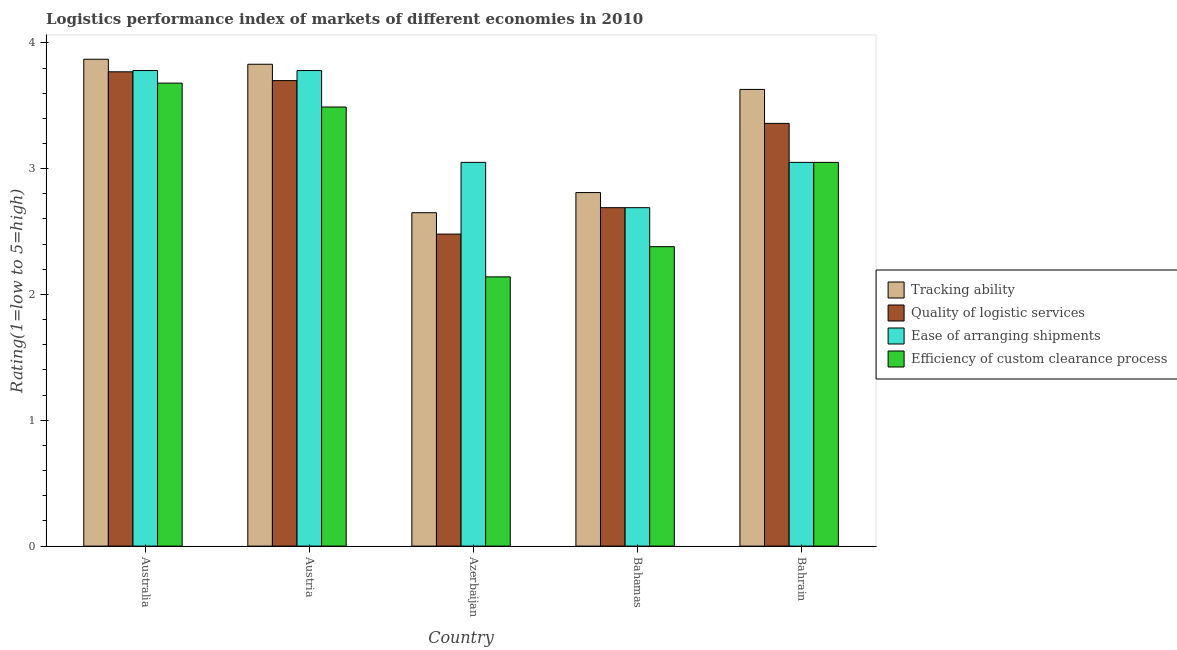How many groups of bars are there?
Make the answer very short. 5. Are the number of bars per tick equal to the number of legend labels?
Keep it short and to the point. Yes. Are the number of bars on each tick of the X-axis equal?
Offer a terse response. Yes. How many bars are there on the 3rd tick from the left?
Give a very brief answer. 4. What is the label of the 5th group of bars from the left?
Your response must be concise. Bahrain. What is the lpi rating of tracking ability in Bahamas?
Make the answer very short. 2.81. Across all countries, what is the maximum lpi rating of efficiency of custom clearance process?
Give a very brief answer. 3.68. Across all countries, what is the minimum lpi rating of quality of logistic services?
Make the answer very short. 2.48. In which country was the lpi rating of efficiency of custom clearance process maximum?
Offer a very short reply. Australia. In which country was the lpi rating of tracking ability minimum?
Offer a very short reply. Azerbaijan. What is the total lpi rating of quality of logistic services in the graph?
Your answer should be compact. 16. What is the difference between the lpi rating of tracking ability in Austria and that in Bahrain?
Your response must be concise. 0.2. What is the difference between the lpi rating of efficiency of custom clearance process in Bahamas and the lpi rating of quality of logistic services in Azerbaijan?
Make the answer very short. -0.1. What is the average lpi rating of ease of arranging shipments per country?
Provide a succinct answer. 3.27. What is the difference between the lpi rating of efficiency of custom clearance process and lpi rating of quality of logistic services in Australia?
Give a very brief answer. -0.09. What is the ratio of the lpi rating of tracking ability in Azerbaijan to that in Bahamas?
Keep it short and to the point. 0.94. Is the lpi rating of tracking ability in Australia less than that in Azerbaijan?
Your answer should be very brief. No. Is the difference between the lpi rating of efficiency of custom clearance process in Australia and Bahrain greater than the difference between the lpi rating of tracking ability in Australia and Bahrain?
Make the answer very short. Yes. What is the difference between the highest and the second highest lpi rating of quality of logistic services?
Offer a terse response. 0.07. What is the difference between the highest and the lowest lpi rating of efficiency of custom clearance process?
Keep it short and to the point. 1.54. In how many countries, is the lpi rating of ease of arranging shipments greater than the average lpi rating of ease of arranging shipments taken over all countries?
Ensure brevity in your answer.  2. Is the sum of the lpi rating of quality of logistic services in Austria and Bahrain greater than the maximum lpi rating of tracking ability across all countries?
Give a very brief answer. Yes. What does the 4th bar from the left in Austria represents?
Make the answer very short. Efficiency of custom clearance process. What does the 1st bar from the right in Bahrain represents?
Give a very brief answer. Efficiency of custom clearance process. Is it the case that in every country, the sum of the lpi rating of tracking ability and lpi rating of quality of logistic services is greater than the lpi rating of ease of arranging shipments?
Ensure brevity in your answer.  Yes. How many bars are there?
Provide a succinct answer. 20. Are all the bars in the graph horizontal?
Keep it short and to the point. No. How many countries are there in the graph?
Provide a short and direct response. 5. What is the difference between two consecutive major ticks on the Y-axis?
Offer a very short reply. 1. Where does the legend appear in the graph?
Your answer should be very brief. Center right. What is the title of the graph?
Keep it short and to the point. Logistics performance index of markets of different economies in 2010. Does "Italy" appear as one of the legend labels in the graph?
Your answer should be very brief. No. What is the label or title of the Y-axis?
Give a very brief answer. Rating(1=low to 5=high). What is the Rating(1=low to 5=high) of Tracking ability in Australia?
Give a very brief answer. 3.87. What is the Rating(1=low to 5=high) in Quality of logistic services in Australia?
Your answer should be very brief. 3.77. What is the Rating(1=low to 5=high) in Ease of arranging shipments in Australia?
Your response must be concise. 3.78. What is the Rating(1=low to 5=high) in Efficiency of custom clearance process in Australia?
Your answer should be very brief. 3.68. What is the Rating(1=low to 5=high) of Tracking ability in Austria?
Offer a terse response. 3.83. What is the Rating(1=low to 5=high) of Ease of arranging shipments in Austria?
Keep it short and to the point. 3.78. What is the Rating(1=low to 5=high) in Efficiency of custom clearance process in Austria?
Your response must be concise. 3.49. What is the Rating(1=low to 5=high) in Tracking ability in Azerbaijan?
Provide a short and direct response. 2.65. What is the Rating(1=low to 5=high) in Quality of logistic services in Azerbaijan?
Keep it short and to the point. 2.48. What is the Rating(1=low to 5=high) of Ease of arranging shipments in Azerbaijan?
Give a very brief answer. 3.05. What is the Rating(1=low to 5=high) of Efficiency of custom clearance process in Azerbaijan?
Offer a very short reply. 2.14. What is the Rating(1=low to 5=high) of Tracking ability in Bahamas?
Make the answer very short. 2.81. What is the Rating(1=low to 5=high) of Quality of logistic services in Bahamas?
Make the answer very short. 2.69. What is the Rating(1=low to 5=high) of Ease of arranging shipments in Bahamas?
Provide a succinct answer. 2.69. What is the Rating(1=low to 5=high) of Efficiency of custom clearance process in Bahamas?
Offer a very short reply. 2.38. What is the Rating(1=low to 5=high) of Tracking ability in Bahrain?
Offer a very short reply. 3.63. What is the Rating(1=low to 5=high) in Quality of logistic services in Bahrain?
Your answer should be compact. 3.36. What is the Rating(1=low to 5=high) in Ease of arranging shipments in Bahrain?
Your answer should be very brief. 3.05. What is the Rating(1=low to 5=high) of Efficiency of custom clearance process in Bahrain?
Provide a succinct answer. 3.05. Across all countries, what is the maximum Rating(1=low to 5=high) in Tracking ability?
Give a very brief answer. 3.87. Across all countries, what is the maximum Rating(1=low to 5=high) in Quality of logistic services?
Offer a very short reply. 3.77. Across all countries, what is the maximum Rating(1=low to 5=high) of Ease of arranging shipments?
Offer a terse response. 3.78. Across all countries, what is the maximum Rating(1=low to 5=high) in Efficiency of custom clearance process?
Your answer should be compact. 3.68. Across all countries, what is the minimum Rating(1=low to 5=high) of Tracking ability?
Provide a succinct answer. 2.65. Across all countries, what is the minimum Rating(1=low to 5=high) of Quality of logistic services?
Ensure brevity in your answer.  2.48. Across all countries, what is the minimum Rating(1=low to 5=high) in Ease of arranging shipments?
Your answer should be compact. 2.69. Across all countries, what is the minimum Rating(1=low to 5=high) of Efficiency of custom clearance process?
Keep it short and to the point. 2.14. What is the total Rating(1=low to 5=high) of Tracking ability in the graph?
Keep it short and to the point. 16.79. What is the total Rating(1=low to 5=high) of Quality of logistic services in the graph?
Offer a very short reply. 16. What is the total Rating(1=low to 5=high) of Ease of arranging shipments in the graph?
Your answer should be compact. 16.35. What is the total Rating(1=low to 5=high) of Efficiency of custom clearance process in the graph?
Offer a terse response. 14.74. What is the difference between the Rating(1=low to 5=high) of Quality of logistic services in Australia and that in Austria?
Offer a very short reply. 0.07. What is the difference between the Rating(1=low to 5=high) in Ease of arranging shipments in Australia and that in Austria?
Offer a very short reply. 0. What is the difference between the Rating(1=low to 5=high) in Efficiency of custom clearance process in Australia and that in Austria?
Offer a terse response. 0.19. What is the difference between the Rating(1=low to 5=high) in Tracking ability in Australia and that in Azerbaijan?
Give a very brief answer. 1.22. What is the difference between the Rating(1=low to 5=high) in Quality of logistic services in Australia and that in Azerbaijan?
Keep it short and to the point. 1.29. What is the difference between the Rating(1=low to 5=high) in Ease of arranging shipments in Australia and that in Azerbaijan?
Provide a succinct answer. 0.73. What is the difference between the Rating(1=low to 5=high) of Efficiency of custom clearance process in Australia and that in Azerbaijan?
Keep it short and to the point. 1.54. What is the difference between the Rating(1=low to 5=high) of Tracking ability in Australia and that in Bahamas?
Offer a terse response. 1.06. What is the difference between the Rating(1=low to 5=high) in Quality of logistic services in Australia and that in Bahamas?
Offer a terse response. 1.08. What is the difference between the Rating(1=low to 5=high) of Ease of arranging shipments in Australia and that in Bahamas?
Keep it short and to the point. 1.09. What is the difference between the Rating(1=low to 5=high) in Tracking ability in Australia and that in Bahrain?
Offer a very short reply. 0.24. What is the difference between the Rating(1=low to 5=high) in Quality of logistic services in Australia and that in Bahrain?
Offer a very short reply. 0.41. What is the difference between the Rating(1=low to 5=high) of Ease of arranging shipments in Australia and that in Bahrain?
Make the answer very short. 0.73. What is the difference between the Rating(1=low to 5=high) of Efficiency of custom clearance process in Australia and that in Bahrain?
Your response must be concise. 0.63. What is the difference between the Rating(1=low to 5=high) in Tracking ability in Austria and that in Azerbaijan?
Your answer should be compact. 1.18. What is the difference between the Rating(1=low to 5=high) in Quality of logistic services in Austria and that in Azerbaijan?
Offer a very short reply. 1.22. What is the difference between the Rating(1=low to 5=high) in Ease of arranging shipments in Austria and that in Azerbaijan?
Your response must be concise. 0.73. What is the difference between the Rating(1=low to 5=high) in Efficiency of custom clearance process in Austria and that in Azerbaijan?
Make the answer very short. 1.35. What is the difference between the Rating(1=low to 5=high) of Ease of arranging shipments in Austria and that in Bahamas?
Ensure brevity in your answer.  1.09. What is the difference between the Rating(1=low to 5=high) in Efficiency of custom clearance process in Austria and that in Bahamas?
Provide a succinct answer. 1.11. What is the difference between the Rating(1=low to 5=high) of Tracking ability in Austria and that in Bahrain?
Provide a succinct answer. 0.2. What is the difference between the Rating(1=low to 5=high) of Quality of logistic services in Austria and that in Bahrain?
Provide a succinct answer. 0.34. What is the difference between the Rating(1=low to 5=high) of Ease of arranging shipments in Austria and that in Bahrain?
Ensure brevity in your answer.  0.73. What is the difference between the Rating(1=low to 5=high) of Efficiency of custom clearance process in Austria and that in Bahrain?
Provide a succinct answer. 0.44. What is the difference between the Rating(1=low to 5=high) in Tracking ability in Azerbaijan and that in Bahamas?
Provide a short and direct response. -0.16. What is the difference between the Rating(1=low to 5=high) in Quality of logistic services in Azerbaijan and that in Bahamas?
Offer a very short reply. -0.21. What is the difference between the Rating(1=low to 5=high) of Ease of arranging shipments in Azerbaijan and that in Bahamas?
Provide a short and direct response. 0.36. What is the difference between the Rating(1=low to 5=high) in Efficiency of custom clearance process in Azerbaijan and that in Bahamas?
Offer a very short reply. -0.24. What is the difference between the Rating(1=low to 5=high) in Tracking ability in Azerbaijan and that in Bahrain?
Give a very brief answer. -0.98. What is the difference between the Rating(1=low to 5=high) of Quality of logistic services in Azerbaijan and that in Bahrain?
Offer a terse response. -0.88. What is the difference between the Rating(1=low to 5=high) in Ease of arranging shipments in Azerbaijan and that in Bahrain?
Ensure brevity in your answer.  0. What is the difference between the Rating(1=low to 5=high) of Efficiency of custom clearance process in Azerbaijan and that in Bahrain?
Provide a succinct answer. -0.91. What is the difference between the Rating(1=low to 5=high) in Tracking ability in Bahamas and that in Bahrain?
Offer a terse response. -0.82. What is the difference between the Rating(1=low to 5=high) in Quality of logistic services in Bahamas and that in Bahrain?
Provide a succinct answer. -0.67. What is the difference between the Rating(1=low to 5=high) of Ease of arranging shipments in Bahamas and that in Bahrain?
Offer a terse response. -0.36. What is the difference between the Rating(1=low to 5=high) in Efficiency of custom clearance process in Bahamas and that in Bahrain?
Make the answer very short. -0.67. What is the difference between the Rating(1=low to 5=high) of Tracking ability in Australia and the Rating(1=low to 5=high) of Quality of logistic services in Austria?
Provide a short and direct response. 0.17. What is the difference between the Rating(1=low to 5=high) in Tracking ability in Australia and the Rating(1=low to 5=high) in Ease of arranging shipments in Austria?
Your response must be concise. 0.09. What is the difference between the Rating(1=low to 5=high) of Tracking ability in Australia and the Rating(1=low to 5=high) of Efficiency of custom clearance process in Austria?
Provide a succinct answer. 0.38. What is the difference between the Rating(1=low to 5=high) in Quality of logistic services in Australia and the Rating(1=low to 5=high) in Ease of arranging shipments in Austria?
Provide a short and direct response. -0.01. What is the difference between the Rating(1=low to 5=high) of Quality of logistic services in Australia and the Rating(1=low to 5=high) of Efficiency of custom clearance process in Austria?
Your answer should be very brief. 0.28. What is the difference between the Rating(1=low to 5=high) in Ease of arranging shipments in Australia and the Rating(1=low to 5=high) in Efficiency of custom clearance process in Austria?
Ensure brevity in your answer.  0.29. What is the difference between the Rating(1=low to 5=high) of Tracking ability in Australia and the Rating(1=low to 5=high) of Quality of logistic services in Azerbaijan?
Your answer should be very brief. 1.39. What is the difference between the Rating(1=low to 5=high) in Tracking ability in Australia and the Rating(1=low to 5=high) in Ease of arranging shipments in Azerbaijan?
Your answer should be compact. 0.82. What is the difference between the Rating(1=low to 5=high) of Tracking ability in Australia and the Rating(1=low to 5=high) of Efficiency of custom clearance process in Azerbaijan?
Your answer should be very brief. 1.73. What is the difference between the Rating(1=low to 5=high) of Quality of logistic services in Australia and the Rating(1=low to 5=high) of Ease of arranging shipments in Azerbaijan?
Offer a terse response. 0.72. What is the difference between the Rating(1=low to 5=high) in Quality of logistic services in Australia and the Rating(1=low to 5=high) in Efficiency of custom clearance process in Azerbaijan?
Give a very brief answer. 1.63. What is the difference between the Rating(1=low to 5=high) of Ease of arranging shipments in Australia and the Rating(1=low to 5=high) of Efficiency of custom clearance process in Azerbaijan?
Keep it short and to the point. 1.64. What is the difference between the Rating(1=low to 5=high) of Tracking ability in Australia and the Rating(1=low to 5=high) of Quality of logistic services in Bahamas?
Your response must be concise. 1.18. What is the difference between the Rating(1=low to 5=high) in Tracking ability in Australia and the Rating(1=low to 5=high) in Ease of arranging shipments in Bahamas?
Make the answer very short. 1.18. What is the difference between the Rating(1=low to 5=high) of Tracking ability in Australia and the Rating(1=low to 5=high) of Efficiency of custom clearance process in Bahamas?
Make the answer very short. 1.49. What is the difference between the Rating(1=low to 5=high) of Quality of logistic services in Australia and the Rating(1=low to 5=high) of Efficiency of custom clearance process in Bahamas?
Keep it short and to the point. 1.39. What is the difference between the Rating(1=low to 5=high) of Ease of arranging shipments in Australia and the Rating(1=low to 5=high) of Efficiency of custom clearance process in Bahamas?
Provide a short and direct response. 1.4. What is the difference between the Rating(1=low to 5=high) of Tracking ability in Australia and the Rating(1=low to 5=high) of Quality of logistic services in Bahrain?
Offer a very short reply. 0.51. What is the difference between the Rating(1=low to 5=high) of Tracking ability in Australia and the Rating(1=low to 5=high) of Ease of arranging shipments in Bahrain?
Make the answer very short. 0.82. What is the difference between the Rating(1=low to 5=high) in Tracking ability in Australia and the Rating(1=low to 5=high) in Efficiency of custom clearance process in Bahrain?
Your response must be concise. 0.82. What is the difference between the Rating(1=low to 5=high) in Quality of logistic services in Australia and the Rating(1=low to 5=high) in Ease of arranging shipments in Bahrain?
Keep it short and to the point. 0.72. What is the difference between the Rating(1=low to 5=high) of Quality of logistic services in Australia and the Rating(1=low to 5=high) of Efficiency of custom clearance process in Bahrain?
Give a very brief answer. 0.72. What is the difference between the Rating(1=low to 5=high) in Ease of arranging shipments in Australia and the Rating(1=low to 5=high) in Efficiency of custom clearance process in Bahrain?
Give a very brief answer. 0.73. What is the difference between the Rating(1=low to 5=high) of Tracking ability in Austria and the Rating(1=low to 5=high) of Quality of logistic services in Azerbaijan?
Your answer should be compact. 1.35. What is the difference between the Rating(1=low to 5=high) in Tracking ability in Austria and the Rating(1=low to 5=high) in Ease of arranging shipments in Azerbaijan?
Make the answer very short. 0.78. What is the difference between the Rating(1=low to 5=high) in Tracking ability in Austria and the Rating(1=low to 5=high) in Efficiency of custom clearance process in Azerbaijan?
Provide a succinct answer. 1.69. What is the difference between the Rating(1=low to 5=high) of Quality of logistic services in Austria and the Rating(1=low to 5=high) of Ease of arranging shipments in Azerbaijan?
Offer a very short reply. 0.65. What is the difference between the Rating(1=low to 5=high) in Quality of logistic services in Austria and the Rating(1=low to 5=high) in Efficiency of custom clearance process in Azerbaijan?
Ensure brevity in your answer.  1.56. What is the difference between the Rating(1=low to 5=high) in Ease of arranging shipments in Austria and the Rating(1=low to 5=high) in Efficiency of custom clearance process in Azerbaijan?
Provide a short and direct response. 1.64. What is the difference between the Rating(1=low to 5=high) in Tracking ability in Austria and the Rating(1=low to 5=high) in Quality of logistic services in Bahamas?
Ensure brevity in your answer.  1.14. What is the difference between the Rating(1=low to 5=high) of Tracking ability in Austria and the Rating(1=low to 5=high) of Ease of arranging shipments in Bahamas?
Offer a terse response. 1.14. What is the difference between the Rating(1=low to 5=high) in Tracking ability in Austria and the Rating(1=low to 5=high) in Efficiency of custom clearance process in Bahamas?
Your answer should be compact. 1.45. What is the difference between the Rating(1=low to 5=high) in Quality of logistic services in Austria and the Rating(1=low to 5=high) in Efficiency of custom clearance process in Bahamas?
Provide a succinct answer. 1.32. What is the difference between the Rating(1=low to 5=high) in Ease of arranging shipments in Austria and the Rating(1=low to 5=high) in Efficiency of custom clearance process in Bahamas?
Provide a short and direct response. 1.4. What is the difference between the Rating(1=low to 5=high) in Tracking ability in Austria and the Rating(1=low to 5=high) in Quality of logistic services in Bahrain?
Your answer should be very brief. 0.47. What is the difference between the Rating(1=low to 5=high) of Tracking ability in Austria and the Rating(1=low to 5=high) of Ease of arranging shipments in Bahrain?
Provide a short and direct response. 0.78. What is the difference between the Rating(1=low to 5=high) of Tracking ability in Austria and the Rating(1=low to 5=high) of Efficiency of custom clearance process in Bahrain?
Give a very brief answer. 0.78. What is the difference between the Rating(1=low to 5=high) of Quality of logistic services in Austria and the Rating(1=low to 5=high) of Ease of arranging shipments in Bahrain?
Offer a terse response. 0.65. What is the difference between the Rating(1=low to 5=high) of Quality of logistic services in Austria and the Rating(1=low to 5=high) of Efficiency of custom clearance process in Bahrain?
Your answer should be compact. 0.65. What is the difference between the Rating(1=low to 5=high) of Ease of arranging shipments in Austria and the Rating(1=low to 5=high) of Efficiency of custom clearance process in Bahrain?
Make the answer very short. 0.73. What is the difference between the Rating(1=low to 5=high) in Tracking ability in Azerbaijan and the Rating(1=low to 5=high) in Quality of logistic services in Bahamas?
Your answer should be very brief. -0.04. What is the difference between the Rating(1=low to 5=high) in Tracking ability in Azerbaijan and the Rating(1=low to 5=high) in Ease of arranging shipments in Bahamas?
Ensure brevity in your answer.  -0.04. What is the difference between the Rating(1=low to 5=high) in Tracking ability in Azerbaijan and the Rating(1=low to 5=high) in Efficiency of custom clearance process in Bahamas?
Give a very brief answer. 0.27. What is the difference between the Rating(1=low to 5=high) of Quality of logistic services in Azerbaijan and the Rating(1=low to 5=high) of Ease of arranging shipments in Bahamas?
Your response must be concise. -0.21. What is the difference between the Rating(1=low to 5=high) of Ease of arranging shipments in Azerbaijan and the Rating(1=low to 5=high) of Efficiency of custom clearance process in Bahamas?
Ensure brevity in your answer.  0.67. What is the difference between the Rating(1=low to 5=high) in Tracking ability in Azerbaijan and the Rating(1=low to 5=high) in Quality of logistic services in Bahrain?
Your response must be concise. -0.71. What is the difference between the Rating(1=low to 5=high) of Tracking ability in Azerbaijan and the Rating(1=low to 5=high) of Efficiency of custom clearance process in Bahrain?
Offer a terse response. -0.4. What is the difference between the Rating(1=low to 5=high) of Quality of logistic services in Azerbaijan and the Rating(1=low to 5=high) of Ease of arranging shipments in Bahrain?
Offer a terse response. -0.57. What is the difference between the Rating(1=low to 5=high) in Quality of logistic services in Azerbaijan and the Rating(1=low to 5=high) in Efficiency of custom clearance process in Bahrain?
Keep it short and to the point. -0.57. What is the difference between the Rating(1=low to 5=high) in Tracking ability in Bahamas and the Rating(1=low to 5=high) in Quality of logistic services in Bahrain?
Your answer should be very brief. -0.55. What is the difference between the Rating(1=low to 5=high) in Tracking ability in Bahamas and the Rating(1=low to 5=high) in Ease of arranging shipments in Bahrain?
Offer a terse response. -0.24. What is the difference between the Rating(1=low to 5=high) in Tracking ability in Bahamas and the Rating(1=low to 5=high) in Efficiency of custom clearance process in Bahrain?
Offer a terse response. -0.24. What is the difference between the Rating(1=low to 5=high) of Quality of logistic services in Bahamas and the Rating(1=low to 5=high) of Ease of arranging shipments in Bahrain?
Make the answer very short. -0.36. What is the difference between the Rating(1=low to 5=high) of Quality of logistic services in Bahamas and the Rating(1=low to 5=high) of Efficiency of custom clearance process in Bahrain?
Your answer should be very brief. -0.36. What is the difference between the Rating(1=low to 5=high) in Ease of arranging shipments in Bahamas and the Rating(1=low to 5=high) in Efficiency of custom clearance process in Bahrain?
Your answer should be compact. -0.36. What is the average Rating(1=low to 5=high) of Tracking ability per country?
Make the answer very short. 3.36. What is the average Rating(1=low to 5=high) of Ease of arranging shipments per country?
Your answer should be compact. 3.27. What is the average Rating(1=low to 5=high) of Efficiency of custom clearance process per country?
Your response must be concise. 2.95. What is the difference between the Rating(1=low to 5=high) in Tracking ability and Rating(1=low to 5=high) in Quality of logistic services in Australia?
Provide a succinct answer. 0.1. What is the difference between the Rating(1=low to 5=high) of Tracking ability and Rating(1=low to 5=high) of Ease of arranging shipments in Australia?
Give a very brief answer. 0.09. What is the difference between the Rating(1=low to 5=high) in Tracking ability and Rating(1=low to 5=high) in Efficiency of custom clearance process in Australia?
Offer a terse response. 0.19. What is the difference between the Rating(1=low to 5=high) in Quality of logistic services and Rating(1=low to 5=high) in Ease of arranging shipments in Australia?
Make the answer very short. -0.01. What is the difference between the Rating(1=low to 5=high) in Quality of logistic services and Rating(1=low to 5=high) in Efficiency of custom clearance process in Australia?
Give a very brief answer. 0.09. What is the difference between the Rating(1=low to 5=high) of Tracking ability and Rating(1=low to 5=high) of Quality of logistic services in Austria?
Give a very brief answer. 0.13. What is the difference between the Rating(1=low to 5=high) of Tracking ability and Rating(1=low to 5=high) of Ease of arranging shipments in Austria?
Offer a very short reply. 0.05. What is the difference between the Rating(1=low to 5=high) of Tracking ability and Rating(1=low to 5=high) of Efficiency of custom clearance process in Austria?
Keep it short and to the point. 0.34. What is the difference between the Rating(1=low to 5=high) in Quality of logistic services and Rating(1=low to 5=high) in Ease of arranging shipments in Austria?
Offer a very short reply. -0.08. What is the difference between the Rating(1=low to 5=high) in Quality of logistic services and Rating(1=low to 5=high) in Efficiency of custom clearance process in Austria?
Offer a terse response. 0.21. What is the difference between the Rating(1=low to 5=high) in Ease of arranging shipments and Rating(1=low to 5=high) in Efficiency of custom clearance process in Austria?
Your answer should be very brief. 0.29. What is the difference between the Rating(1=low to 5=high) in Tracking ability and Rating(1=low to 5=high) in Quality of logistic services in Azerbaijan?
Offer a very short reply. 0.17. What is the difference between the Rating(1=low to 5=high) in Tracking ability and Rating(1=low to 5=high) in Ease of arranging shipments in Azerbaijan?
Make the answer very short. -0.4. What is the difference between the Rating(1=low to 5=high) in Tracking ability and Rating(1=low to 5=high) in Efficiency of custom clearance process in Azerbaijan?
Offer a very short reply. 0.51. What is the difference between the Rating(1=low to 5=high) of Quality of logistic services and Rating(1=low to 5=high) of Ease of arranging shipments in Azerbaijan?
Offer a terse response. -0.57. What is the difference between the Rating(1=low to 5=high) in Quality of logistic services and Rating(1=low to 5=high) in Efficiency of custom clearance process in Azerbaijan?
Your answer should be very brief. 0.34. What is the difference between the Rating(1=low to 5=high) of Ease of arranging shipments and Rating(1=low to 5=high) of Efficiency of custom clearance process in Azerbaijan?
Make the answer very short. 0.91. What is the difference between the Rating(1=low to 5=high) of Tracking ability and Rating(1=low to 5=high) of Quality of logistic services in Bahamas?
Give a very brief answer. 0.12. What is the difference between the Rating(1=low to 5=high) of Tracking ability and Rating(1=low to 5=high) of Ease of arranging shipments in Bahamas?
Offer a very short reply. 0.12. What is the difference between the Rating(1=low to 5=high) of Tracking ability and Rating(1=low to 5=high) of Efficiency of custom clearance process in Bahamas?
Ensure brevity in your answer.  0.43. What is the difference between the Rating(1=low to 5=high) in Quality of logistic services and Rating(1=low to 5=high) in Efficiency of custom clearance process in Bahamas?
Provide a succinct answer. 0.31. What is the difference between the Rating(1=low to 5=high) in Ease of arranging shipments and Rating(1=low to 5=high) in Efficiency of custom clearance process in Bahamas?
Provide a short and direct response. 0.31. What is the difference between the Rating(1=low to 5=high) in Tracking ability and Rating(1=low to 5=high) in Quality of logistic services in Bahrain?
Keep it short and to the point. 0.27. What is the difference between the Rating(1=low to 5=high) of Tracking ability and Rating(1=low to 5=high) of Ease of arranging shipments in Bahrain?
Your answer should be very brief. 0.58. What is the difference between the Rating(1=low to 5=high) of Tracking ability and Rating(1=low to 5=high) of Efficiency of custom clearance process in Bahrain?
Provide a short and direct response. 0.58. What is the difference between the Rating(1=low to 5=high) of Quality of logistic services and Rating(1=low to 5=high) of Ease of arranging shipments in Bahrain?
Keep it short and to the point. 0.31. What is the difference between the Rating(1=low to 5=high) in Quality of logistic services and Rating(1=low to 5=high) in Efficiency of custom clearance process in Bahrain?
Offer a very short reply. 0.31. What is the difference between the Rating(1=low to 5=high) in Ease of arranging shipments and Rating(1=low to 5=high) in Efficiency of custom clearance process in Bahrain?
Keep it short and to the point. 0. What is the ratio of the Rating(1=low to 5=high) in Tracking ability in Australia to that in Austria?
Make the answer very short. 1.01. What is the ratio of the Rating(1=low to 5=high) of Quality of logistic services in Australia to that in Austria?
Provide a short and direct response. 1.02. What is the ratio of the Rating(1=low to 5=high) of Efficiency of custom clearance process in Australia to that in Austria?
Offer a very short reply. 1.05. What is the ratio of the Rating(1=low to 5=high) in Tracking ability in Australia to that in Azerbaijan?
Ensure brevity in your answer.  1.46. What is the ratio of the Rating(1=low to 5=high) of Quality of logistic services in Australia to that in Azerbaijan?
Offer a terse response. 1.52. What is the ratio of the Rating(1=low to 5=high) of Ease of arranging shipments in Australia to that in Azerbaijan?
Provide a succinct answer. 1.24. What is the ratio of the Rating(1=low to 5=high) in Efficiency of custom clearance process in Australia to that in Azerbaijan?
Provide a succinct answer. 1.72. What is the ratio of the Rating(1=low to 5=high) in Tracking ability in Australia to that in Bahamas?
Your answer should be compact. 1.38. What is the ratio of the Rating(1=low to 5=high) of Quality of logistic services in Australia to that in Bahamas?
Your answer should be very brief. 1.4. What is the ratio of the Rating(1=low to 5=high) in Ease of arranging shipments in Australia to that in Bahamas?
Your answer should be very brief. 1.41. What is the ratio of the Rating(1=low to 5=high) of Efficiency of custom clearance process in Australia to that in Bahamas?
Give a very brief answer. 1.55. What is the ratio of the Rating(1=low to 5=high) in Tracking ability in Australia to that in Bahrain?
Your response must be concise. 1.07. What is the ratio of the Rating(1=low to 5=high) of Quality of logistic services in Australia to that in Bahrain?
Give a very brief answer. 1.12. What is the ratio of the Rating(1=low to 5=high) in Ease of arranging shipments in Australia to that in Bahrain?
Provide a succinct answer. 1.24. What is the ratio of the Rating(1=low to 5=high) of Efficiency of custom clearance process in Australia to that in Bahrain?
Provide a succinct answer. 1.21. What is the ratio of the Rating(1=low to 5=high) in Tracking ability in Austria to that in Azerbaijan?
Ensure brevity in your answer.  1.45. What is the ratio of the Rating(1=low to 5=high) in Quality of logistic services in Austria to that in Azerbaijan?
Give a very brief answer. 1.49. What is the ratio of the Rating(1=low to 5=high) of Ease of arranging shipments in Austria to that in Azerbaijan?
Ensure brevity in your answer.  1.24. What is the ratio of the Rating(1=low to 5=high) in Efficiency of custom clearance process in Austria to that in Azerbaijan?
Keep it short and to the point. 1.63. What is the ratio of the Rating(1=low to 5=high) of Tracking ability in Austria to that in Bahamas?
Provide a short and direct response. 1.36. What is the ratio of the Rating(1=low to 5=high) in Quality of logistic services in Austria to that in Bahamas?
Your response must be concise. 1.38. What is the ratio of the Rating(1=low to 5=high) in Ease of arranging shipments in Austria to that in Bahamas?
Your response must be concise. 1.41. What is the ratio of the Rating(1=low to 5=high) of Efficiency of custom clearance process in Austria to that in Bahamas?
Provide a short and direct response. 1.47. What is the ratio of the Rating(1=low to 5=high) of Tracking ability in Austria to that in Bahrain?
Keep it short and to the point. 1.06. What is the ratio of the Rating(1=low to 5=high) of Quality of logistic services in Austria to that in Bahrain?
Offer a very short reply. 1.1. What is the ratio of the Rating(1=low to 5=high) in Ease of arranging shipments in Austria to that in Bahrain?
Make the answer very short. 1.24. What is the ratio of the Rating(1=low to 5=high) in Efficiency of custom clearance process in Austria to that in Bahrain?
Ensure brevity in your answer.  1.14. What is the ratio of the Rating(1=low to 5=high) in Tracking ability in Azerbaijan to that in Bahamas?
Provide a short and direct response. 0.94. What is the ratio of the Rating(1=low to 5=high) in Quality of logistic services in Azerbaijan to that in Bahamas?
Ensure brevity in your answer.  0.92. What is the ratio of the Rating(1=low to 5=high) in Ease of arranging shipments in Azerbaijan to that in Bahamas?
Give a very brief answer. 1.13. What is the ratio of the Rating(1=low to 5=high) in Efficiency of custom clearance process in Azerbaijan to that in Bahamas?
Your answer should be compact. 0.9. What is the ratio of the Rating(1=low to 5=high) of Tracking ability in Azerbaijan to that in Bahrain?
Keep it short and to the point. 0.73. What is the ratio of the Rating(1=low to 5=high) in Quality of logistic services in Azerbaijan to that in Bahrain?
Your response must be concise. 0.74. What is the ratio of the Rating(1=low to 5=high) of Efficiency of custom clearance process in Azerbaijan to that in Bahrain?
Provide a succinct answer. 0.7. What is the ratio of the Rating(1=low to 5=high) of Tracking ability in Bahamas to that in Bahrain?
Provide a short and direct response. 0.77. What is the ratio of the Rating(1=low to 5=high) in Quality of logistic services in Bahamas to that in Bahrain?
Give a very brief answer. 0.8. What is the ratio of the Rating(1=low to 5=high) of Ease of arranging shipments in Bahamas to that in Bahrain?
Offer a terse response. 0.88. What is the ratio of the Rating(1=low to 5=high) in Efficiency of custom clearance process in Bahamas to that in Bahrain?
Make the answer very short. 0.78. What is the difference between the highest and the second highest Rating(1=low to 5=high) of Tracking ability?
Your answer should be compact. 0.04. What is the difference between the highest and the second highest Rating(1=low to 5=high) of Quality of logistic services?
Offer a very short reply. 0.07. What is the difference between the highest and the second highest Rating(1=low to 5=high) of Ease of arranging shipments?
Your answer should be very brief. 0. What is the difference between the highest and the second highest Rating(1=low to 5=high) of Efficiency of custom clearance process?
Your answer should be very brief. 0.19. What is the difference between the highest and the lowest Rating(1=low to 5=high) of Tracking ability?
Offer a very short reply. 1.22. What is the difference between the highest and the lowest Rating(1=low to 5=high) of Quality of logistic services?
Your answer should be compact. 1.29. What is the difference between the highest and the lowest Rating(1=low to 5=high) of Ease of arranging shipments?
Make the answer very short. 1.09. What is the difference between the highest and the lowest Rating(1=low to 5=high) of Efficiency of custom clearance process?
Provide a short and direct response. 1.54. 